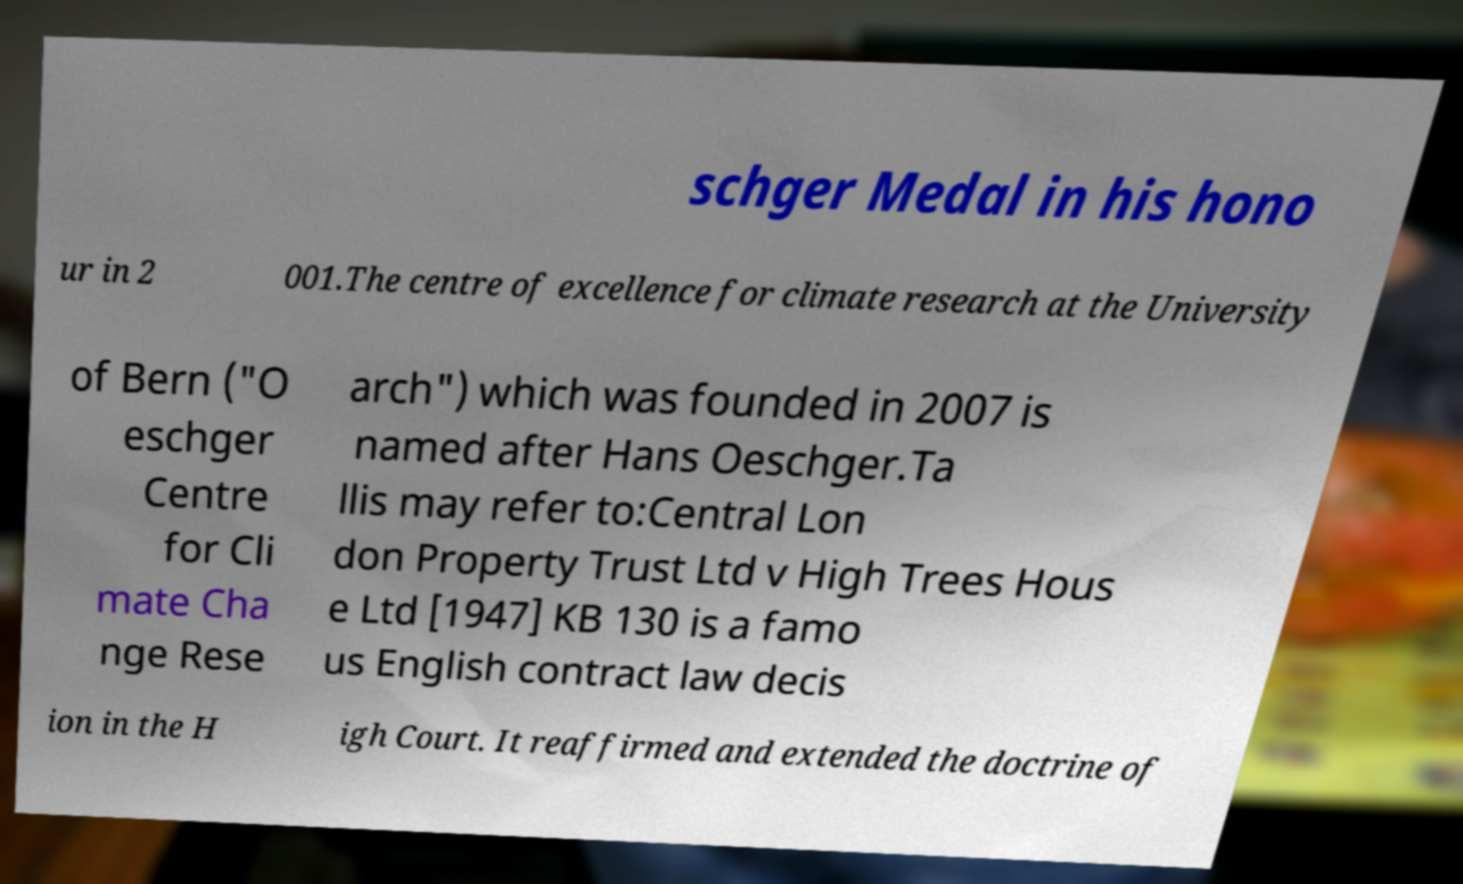Please identify and transcribe the text found in this image. schger Medal in his hono ur in 2 001.The centre of excellence for climate research at the University of Bern ("O eschger Centre for Cli mate Cha nge Rese arch") which was founded in 2007 is named after Hans Oeschger.Ta llis may refer to:Central Lon don Property Trust Ltd v High Trees Hous e Ltd [1947] KB 130 is a famo us English contract law decis ion in the H igh Court. It reaffirmed and extended the doctrine of 